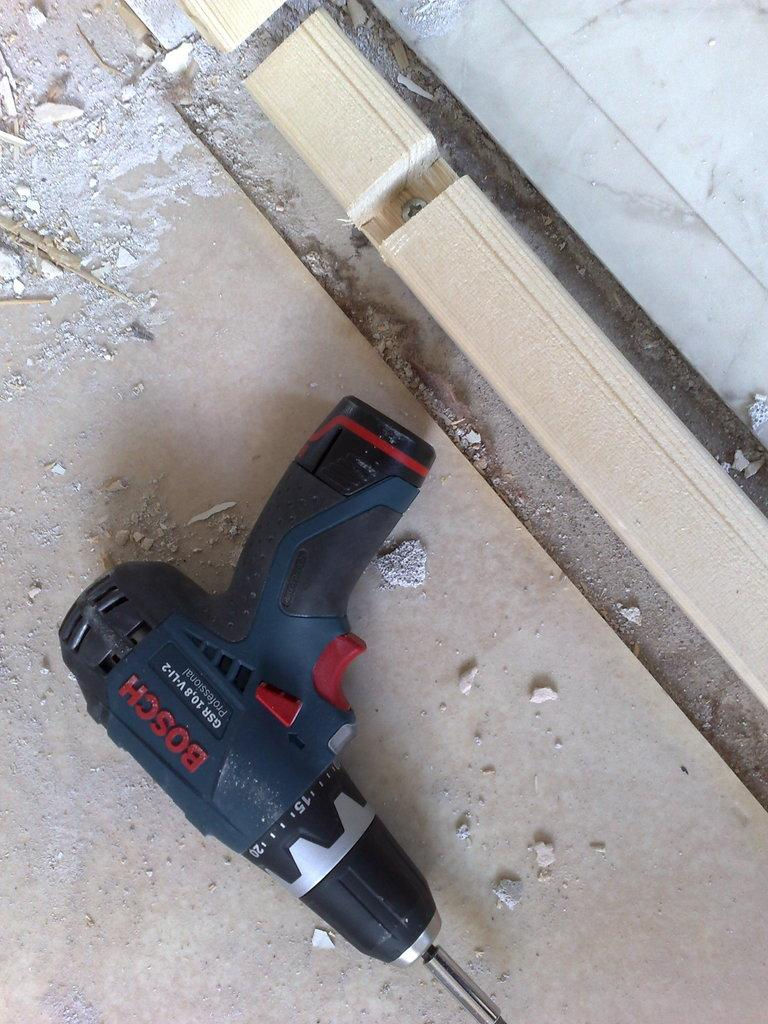What is the main object in the image? There is a drilling machine in the image. Where is the drilling machine located? The drilling machine is placed on the floor. What material is present in the image? There is wood in the image. What can be seen in the background of the image? There is a wall in the image. How many bulbs are attached to the drilling machine in the image? There are no bulbs attached to the drilling machine in the image. What type of test is being conducted with the drilling machine in the image? There is no test being conducted with the drilling machine in the image. 